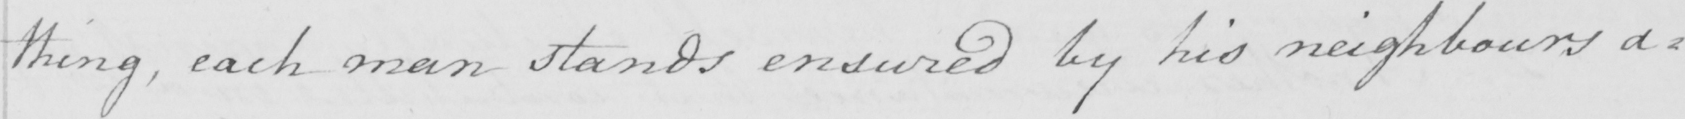Can you tell me what this handwritten text says? thing , each man stands ensured by his neighbours a= 